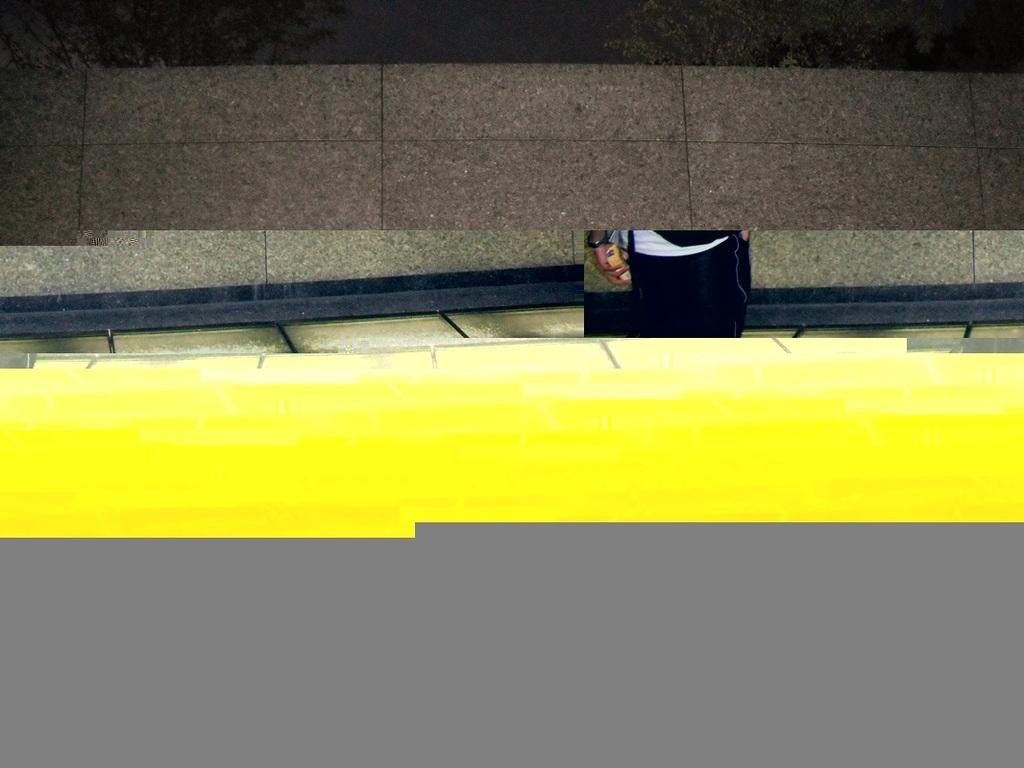What is visible at the top of the image? There is a floor visible at the top of the image. What can be seen in the middle of the image? There is a person's hand holding something in the middle of the image. What type of table is present in the image? There is no table present in the image; only a floor and a person's hand holding something are visible. What is the person talking about in the image? There is no indication of a conversation or talking in the image, as only a person's hand holding something is visible. 